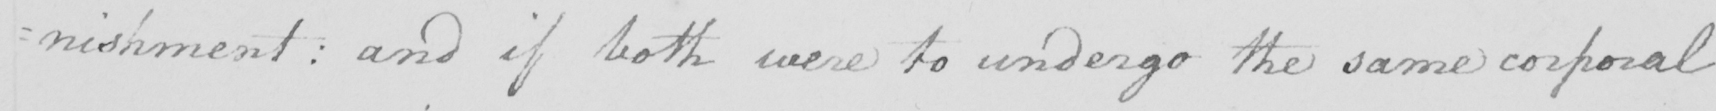Transcribe the text shown in this historical manuscript line. : nishment :  and if both were to undergo the same corporal 